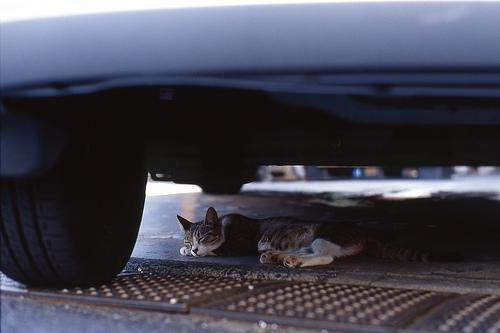Question: what color is the drain cover?
Choices:
A. Gray.
B. Brown.
C. Silver.
D. Yellow.
Answer with the letter. Answer: B Question: what is sleeping under the car?
Choices:
A. A dog.
B. A cat.
C. A homeless man.
D. A lizard.
Answer with the letter. Answer: B Question: how many cats are in this picture?
Choices:
A. 2.
B. 3.
C. 4.
D. 1.
Answer with the letter. Answer: D Question: where is the cat sleeping?
Choices:
A. The bed.
B. The grass.
C. The couch.
D. Under a car.
Answer with the letter. Answer: D Question: what is above the cat?
Choices:
A. The sky.
B. A car.
C. The ceiling.
D. Clouds.
Answer with the letter. Answer: B 